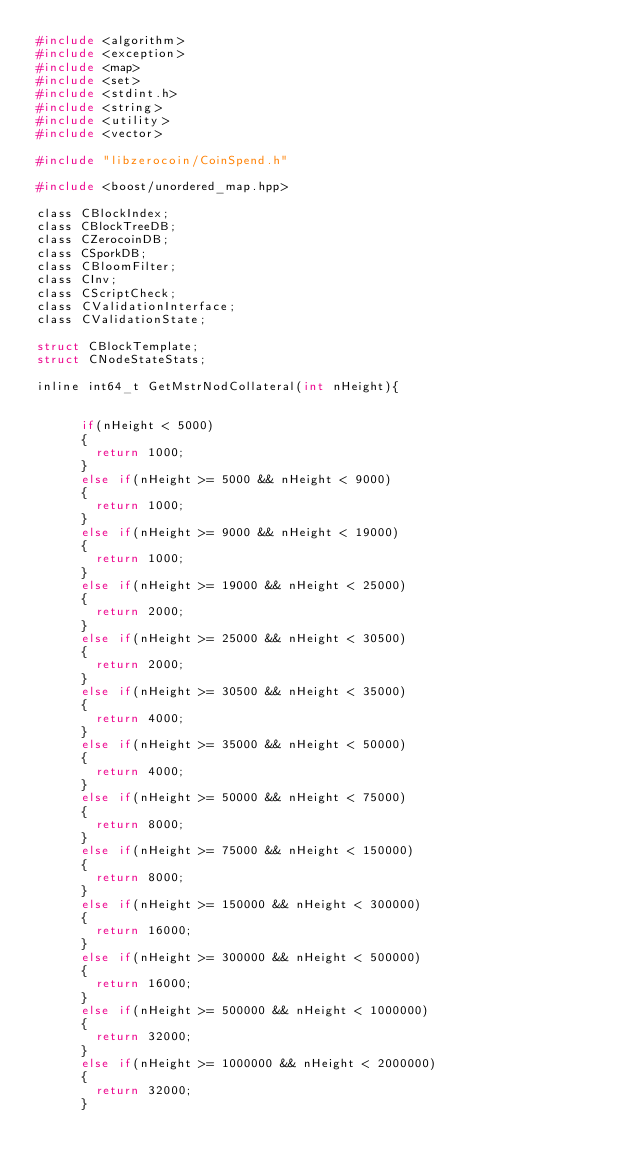Convert code to text. <code><loc_0><loc_0><loc_500><loc_500><_C_>#include <algorithm>
#include <exception>
#include <map>
#include <set>
#include <stdint.h>
#include <string>
#include <utility>
#include <vector>

#include "libzerocoin/CoinSpend.h"

#include <boost/unordered_map.hpp>

class CBlockIndex;
class CBlockTreeDB;
class CZerocoinDB;
class CSporkDB;
class CBloomFilter;
class CInv;
class CScriptCheck;
class CValidationInterface;
class CValidationState;

struct CBlockTemplate;
struct CNodeStateStats;

inline int64_t GetMstrNodCollateral(int nHeight){


      if(nHeight < 5000)
      {
        return 1000;
      }
      else if(nHeight >= 5000 && nHeight < 9000)
      {
        return 1000;
      }
      else if(nHeight >= 9000 && nHeight < 19000)
      {
        return 1000;
      }
      else if(nHeight >= 19000 && nHeight < 25000)
      {
        return 2000;
      }
      else if(nHeight >= 25000 && nHeight < 30500)
      {
        return 2000;
      }
      else if(nHeight >= 30500 && nHeight < 35000)
      {
        return 4000;
      }
      else if(nHeight >= 35000 && nHeight < 50000)
      {
        return 4000;
      }
      else if(nHeight >= 50000 && nHeight < 75000)
      {
        return 8000;
      }
      else if(nHeight >= 75000 && nHeight < 150000)
      {
        return 8000;
      }
      else if(nHeight >= 150000 && nHeight < 300000)
      {
        return 16000;
      }
      else if(nHeight >= 300000 && nHeight < 500000)
      {
        return 16000;
      }
      else if(nHeight >= 500000 && nHeight < 1000000)
      {
        return 32000;
      }
      else if(nHeight >= 1000000 && nHeight < 2000000)
      {
        return 32000;
      }</code> 